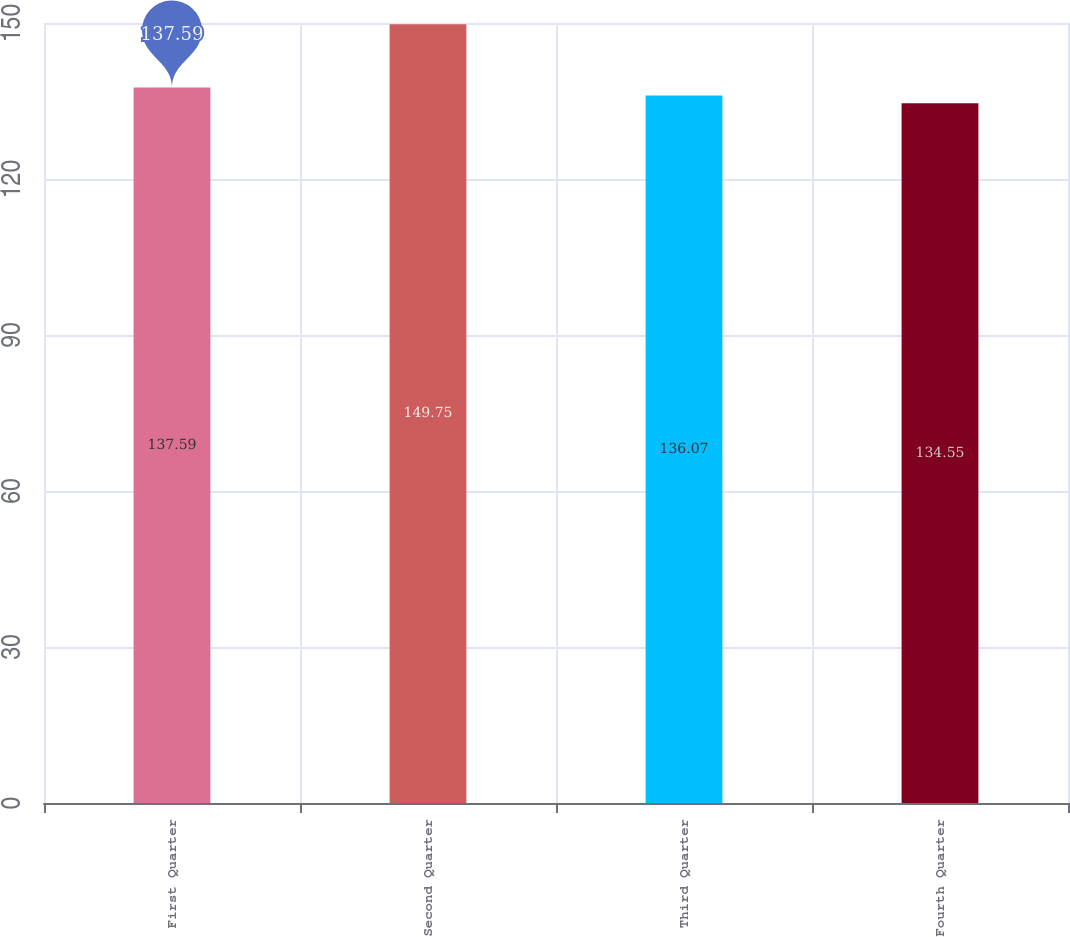Convert chart to OTSL. <chart><loc_0><loc_0><loc_500><loc_500><bar_chart><fcel>First Quarter<fcel>Second Quarter<fcel>Third Quarter<fcel>Fourth Quarter<nl><fcel>137.59<fcel>149.75<fcel>136.07<fcel>134.55<nl></chart> 